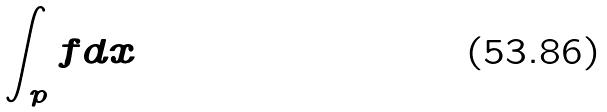<formula> <loc_0><loc_0><loc_500><loc_500>\int _ { p } f d x</formula> 